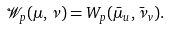Convert formula to latex. <formula><loc_0><loc_0><loc_500><loc_500>\mathcal { W } _ { p } ( \mu , \nu ) = W _ { p } ( \bar { \mu } _ { u } , \bar { \nu } _ { v } ) .</formula> 